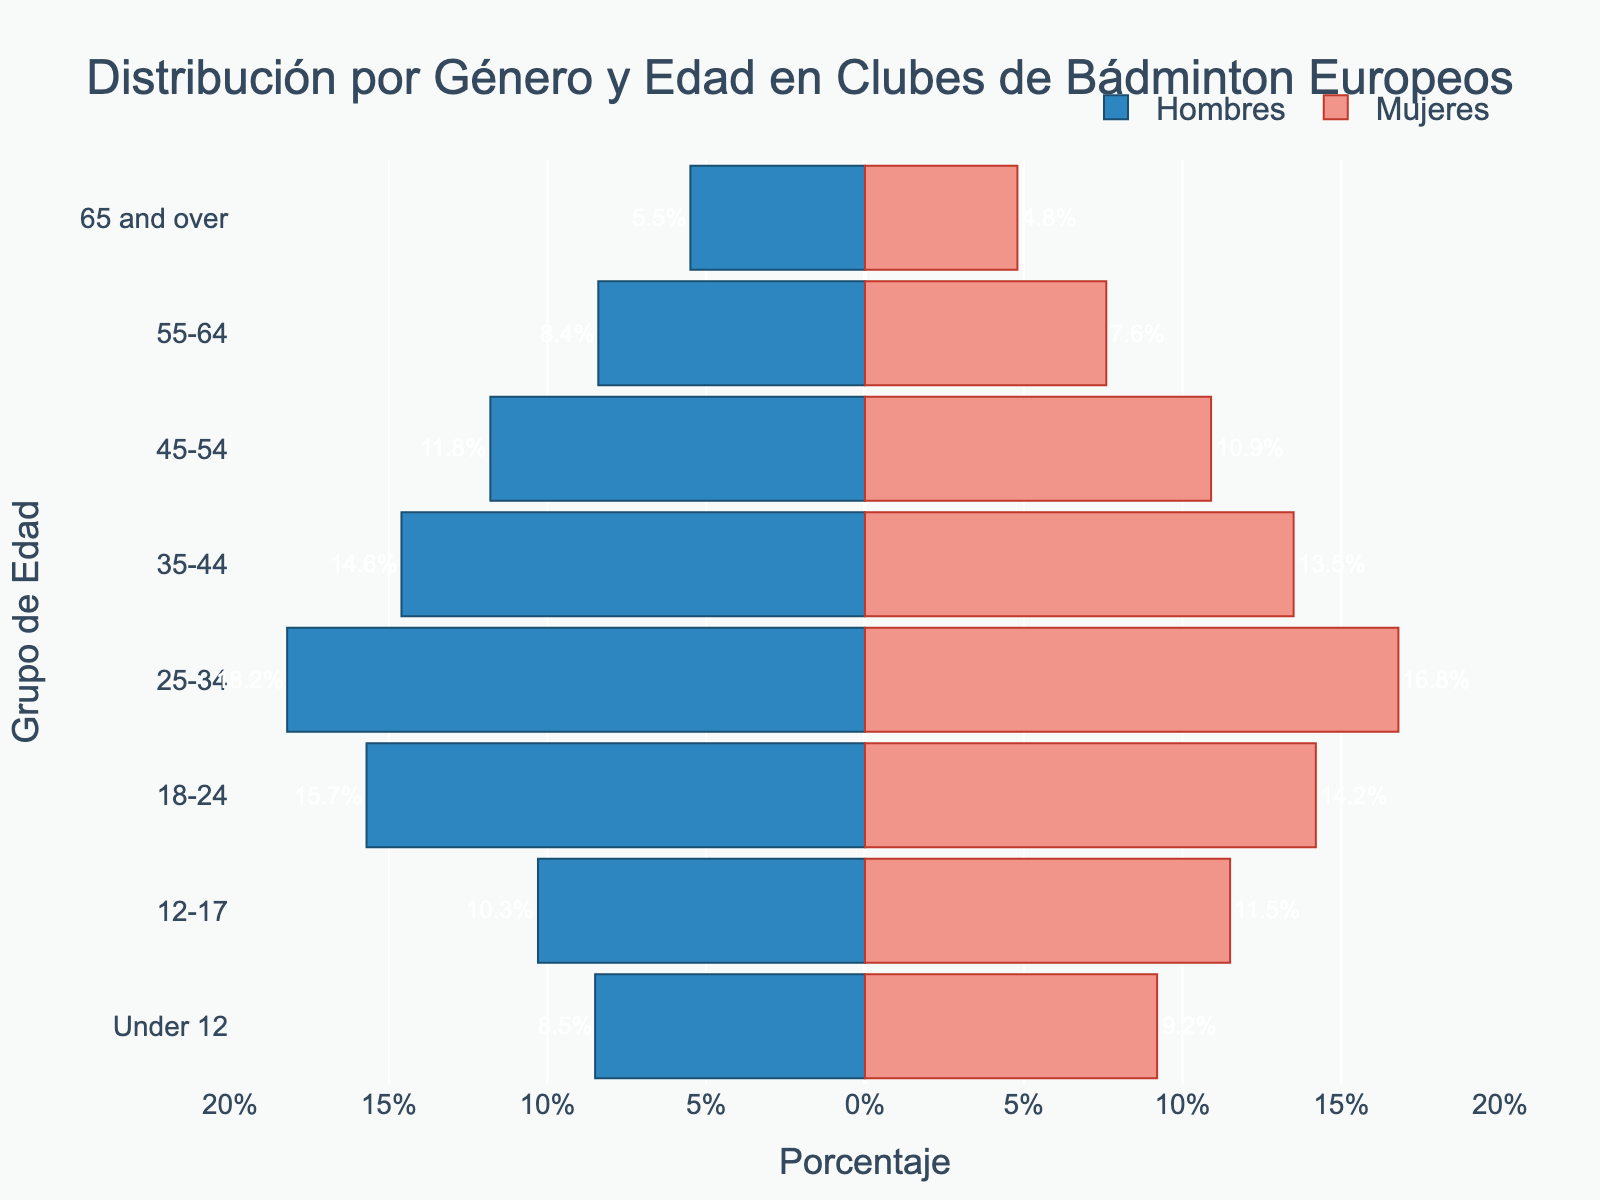What is the title of the figure? The title of the figure is usually placed at the top center of the plot. By closely examining the title in the Population Pyramid, we can identify it.
Answer: Distribución por Género y Edad en Clubes de Bádminton Europeos Which age group has the highest percentage of male members? To find the age group with the highest percentage of male members, look at the bars representing males (colored blue) and find the longest one. This corresponds to the age group 25-34.
Answer: 25-34 Which age group has a higher percentage of female members than male members? By comparing the lengths of the bars for each age group, we can identify that the groups Under 12 and 12-17 have longer bars for females (red) compared to males (blue).
Answer: Under 12, 12-17 What is the difference in percentage between male and female members in the 25-34 age group? To find this, subtract the percentage of female members from the percentage of male members in the 25-34 age group: 18.2% - 16.8%.
Answer: 1.4% How many age groups have more males than females? By carefully comparing the lengths of the blue and red bars for each age group, we can see that there are five groups where the blue bar is longer: 18-24, 25-34, 35-44, 45-54, and 55-64.
Answer: 5 Which age group has the smallest difference in percentage between male and female members? To find the smallest difference, calculate the absolute differences for each age group and then identify the smallest one. The 35-44 age group has a difference of 14.6% - 13.5% = 1.1%, which is the smallest.
Answer: 35-44 In the age group 65 and over, is the percentage of male or female members higher? By comparing the bars for the age group 65 and over, it's evident that the blue bar (males) is longer than the red bar (females).
Answer: Male members Which two age groups have almost equal percentages of female members? The age groups Under 12 and 65 and over have the following percentages of female members: 9.2% and 4.8%, respectively. Though they are different, since the question asks for almost equal, 12-17 (11.5%) and 18-24 (14.2%) are very close.
Answer: 12-17, 18-24 What is the combined percentage of male and female members in the 45-54 age group? To find the combined percentage, add the percentages of male and female members in the 45-54 age group: 11.8% + 10.9%.
Answer: 22.7% Which gender has more members in the age group 35-44? By comparing the lengths of the bars for the age group 35-44, the blue bar (males) is longer than the red bar (females).
Answer: Male members 